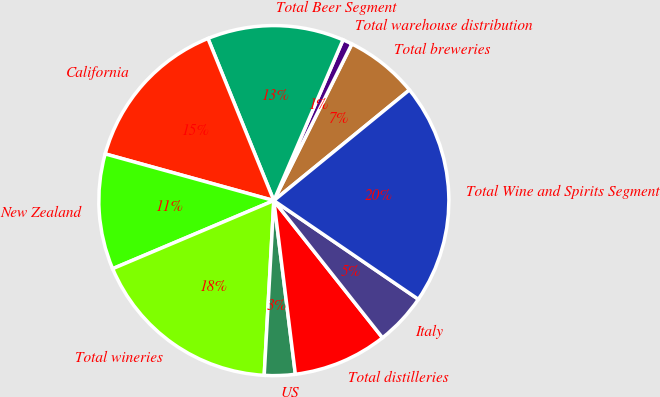<chart> <loc_0><loc_0><loc_500><loc_500><pie_chart><fcel>Total breweries<fcel>Total warehouse distribution<fcel>Total Beer Segment<fcel>California<fcel>New Zealand<fcel>Total wineries<fcel>US<fcel>Total distilleries<fcel>Italy<fcel>Total Wine and Spirits Segment<nl><fcel>6.75%<fcel>0.89%<fcel>12.61%<fcel>14.56%<fcel>10.66%<fcel>17.76%<fcel>2.84%<fcel>8.7%<fcel>4.8%<fcel>20.43%<nl></chart> 